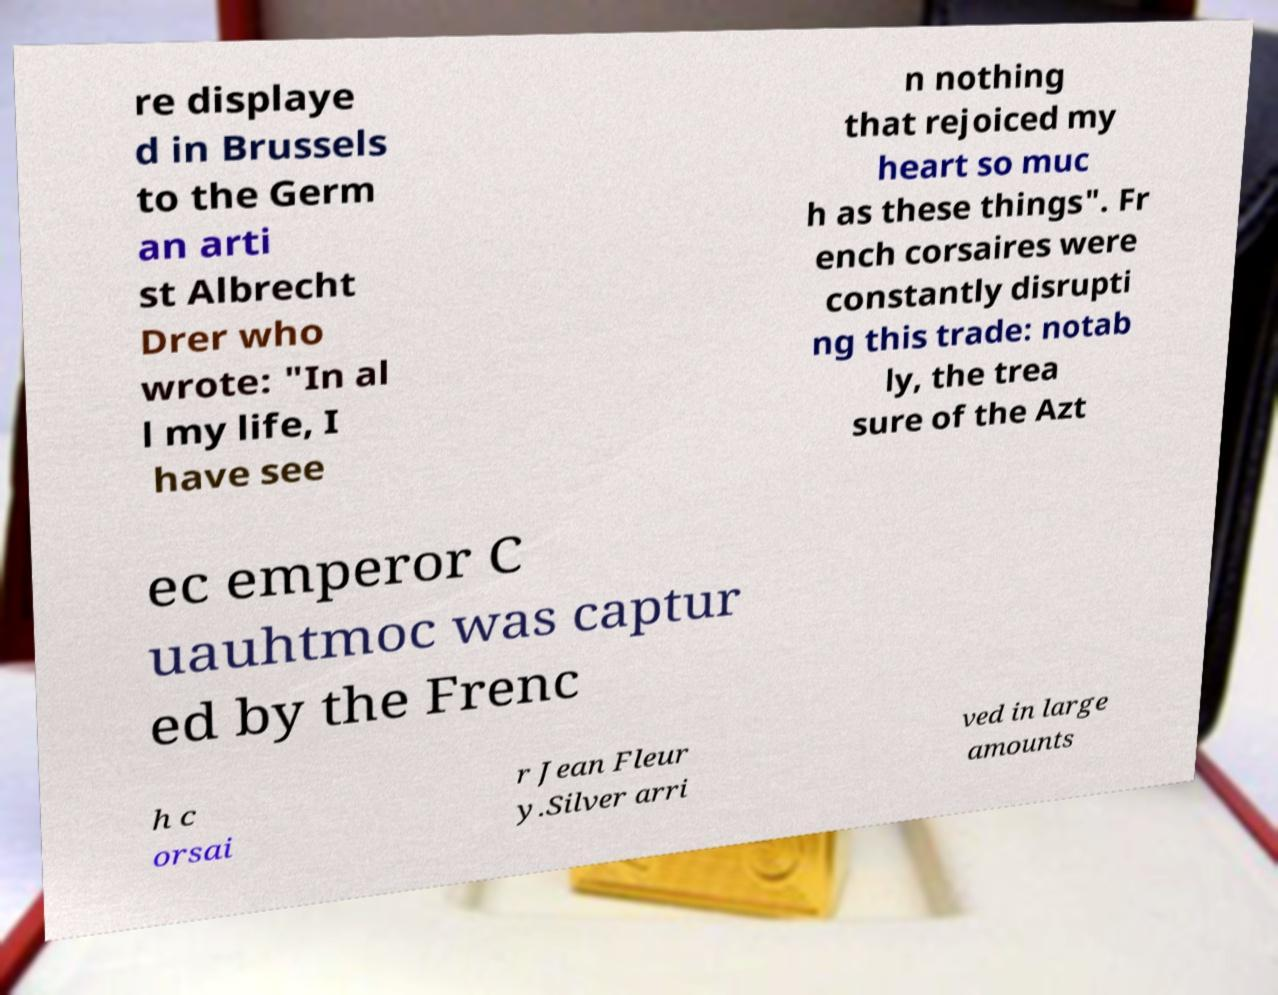Please read and relay the text visible in this image. What does it say? re displaye d in Brussels to the Germ an arti st Albrecht Drer who wrote: "In al l my life, I have see n nothing that rejoiced my heart so muc h as these things". Fr ench corsaires were constantly disrupti ng this trade: notab ly, the trea sure of the Azt ec emperor C uauhtmoc was captur ed by the Frenc h c orsai r Jean Fleur y.Silver arri ved in large amounts 